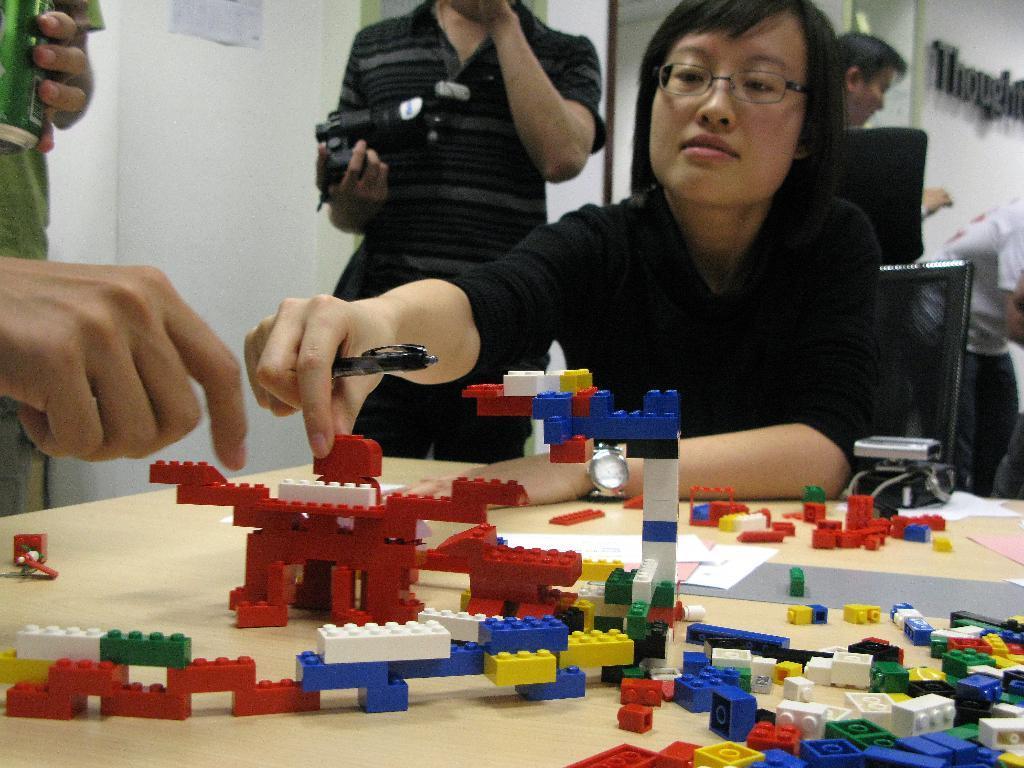Please provide a concise description of this image. In this image we can see few people and they are holding some objects in their hands. There are Lego objects on the table. A lady is sitting on the chair. There is some text on the wall at the right side of the image. There is a poster on the wall at the top left side of the image. 